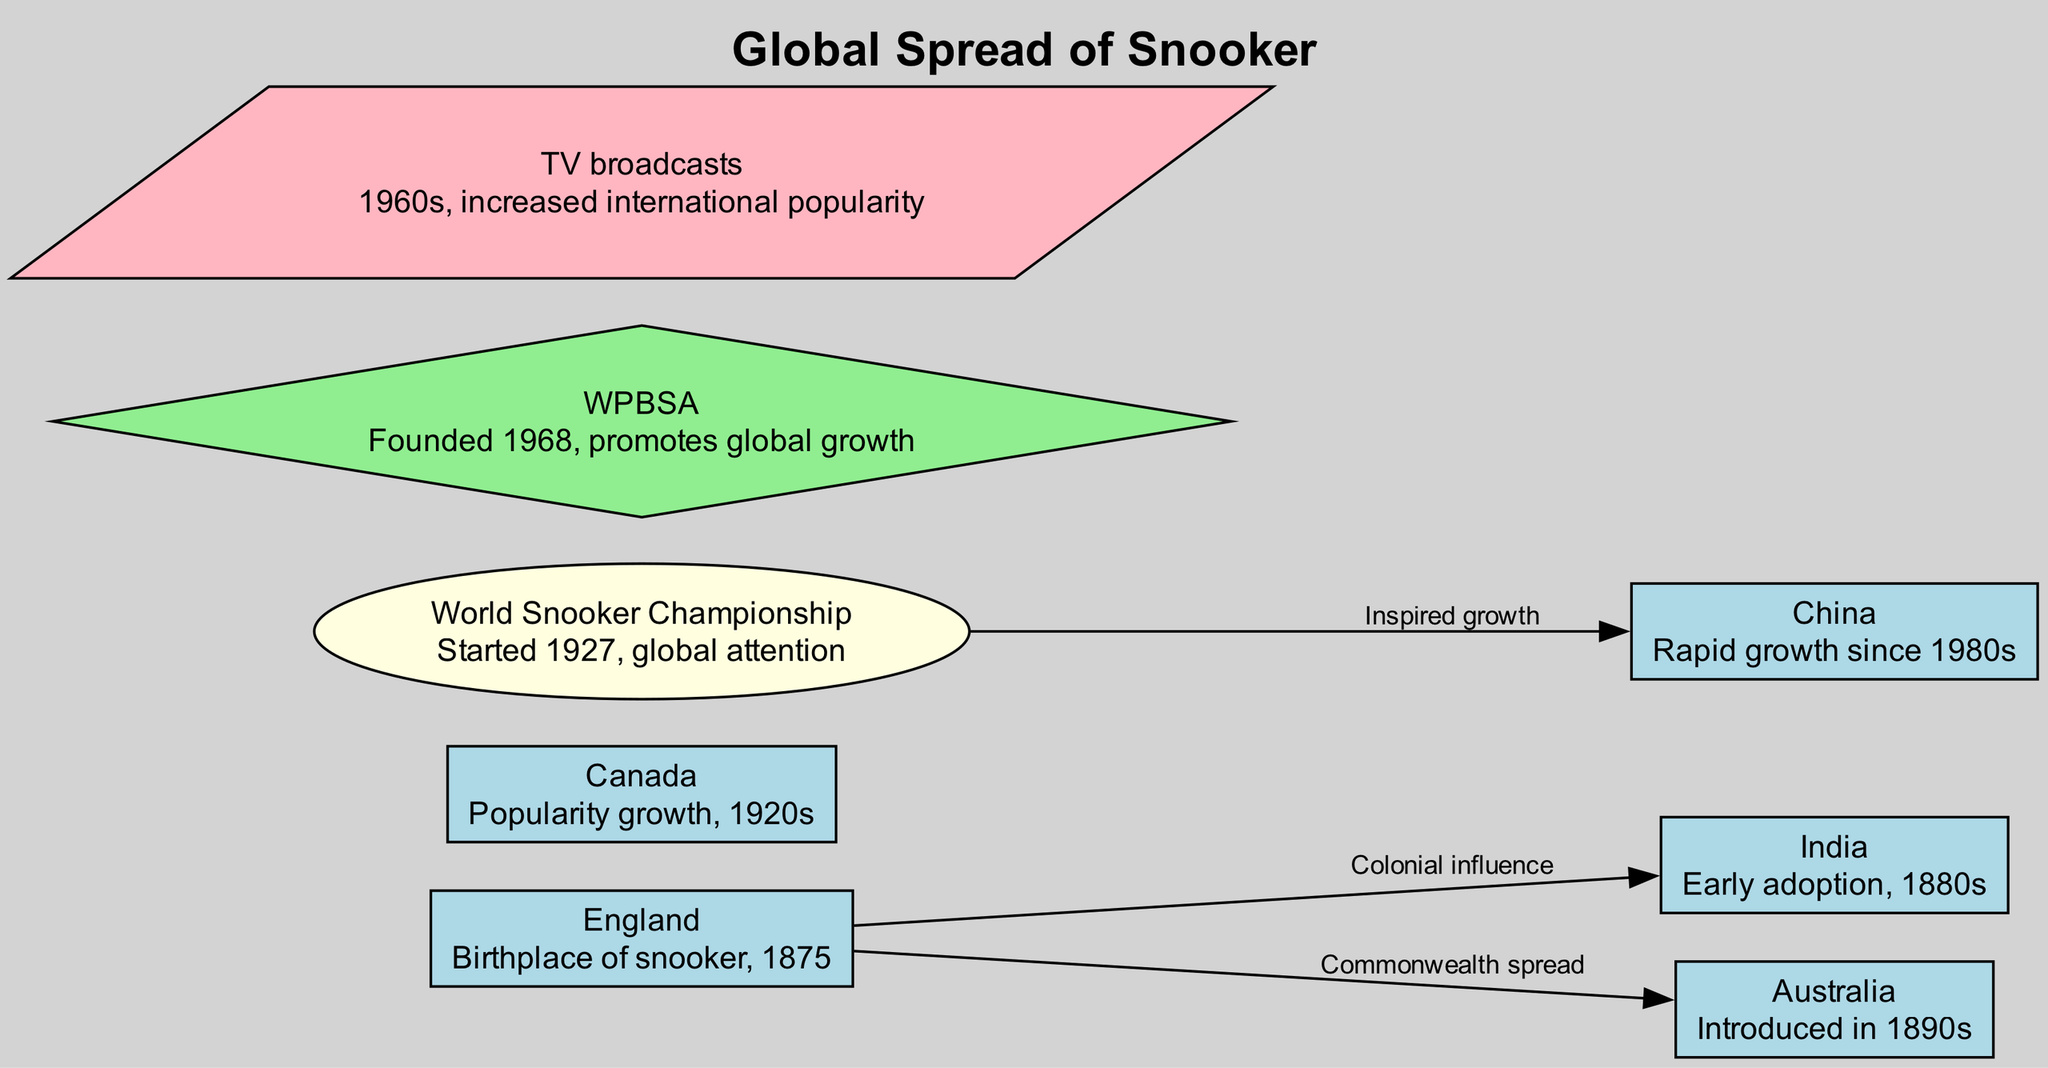What is the birthplace of snooker? According to the diagram, England is marked as the birthplace of snooker and is associated with the year 1875. This information is clearly stated as part of the details associated with the country node.
Answer: England Which country adopted snooker in the 1880s? The diagram indicates that India was an early adopter of snooker in the 1880s. This information is directly obtained from the details linked to the country node representing India.
Answer: India How many countries are mentioned in the diagram? The diagram lists a total of five countries: England, India, Australia, Canada, and China. Therefore, by counting the individual country nodes, the total is determined.
Answer: Five What event started in 1927 that increased the global attention for snooker? The World Snooker Championship is noted in the diagram as having started in 1927. The label of this event node explicitly states this information.
Answer: World Snooker Championship What connection does Australia have with England according to the diagram? The diagram shows a connection from England to Australia labeled 'Commonwealth spread.' This connection indicates how snooker was introduced in Australia due to historical links with England.
Answer: Commonwealth spread Which organization was founded to promote global growth of snooker? The diagram highlights the WPBSA (World Professional Billiards and Snooker Association) as the organization founded in 1968 with a mission to promote the global growth of snooker. This is explicitly mentioned in the details of the organization node.
Answer: WPBSA Which country has experienced rapid growth in snooker since the 1980s? The diagram specifies that China has seen rapid growth in snooker since the 1980s, as noted in the details section of the country node for China.
Answer: China What milestone contributed to increased international popularity of snooker in the 1960s? The TV broadcasts milestone is pointed out in the diagram as a significant factor that contributed to the increased international popularity of the sport during the 1960s.
Answer: TV broadcasts What was the relationship between the World Snooker Championship and China? The diagram shows a connection from the World Snooker Championship to China labeled 'Inspired growth.' This indicates that the World Snooker Championship had a positive influence on the growth of the sport in China.
Answer: Inspired growth 